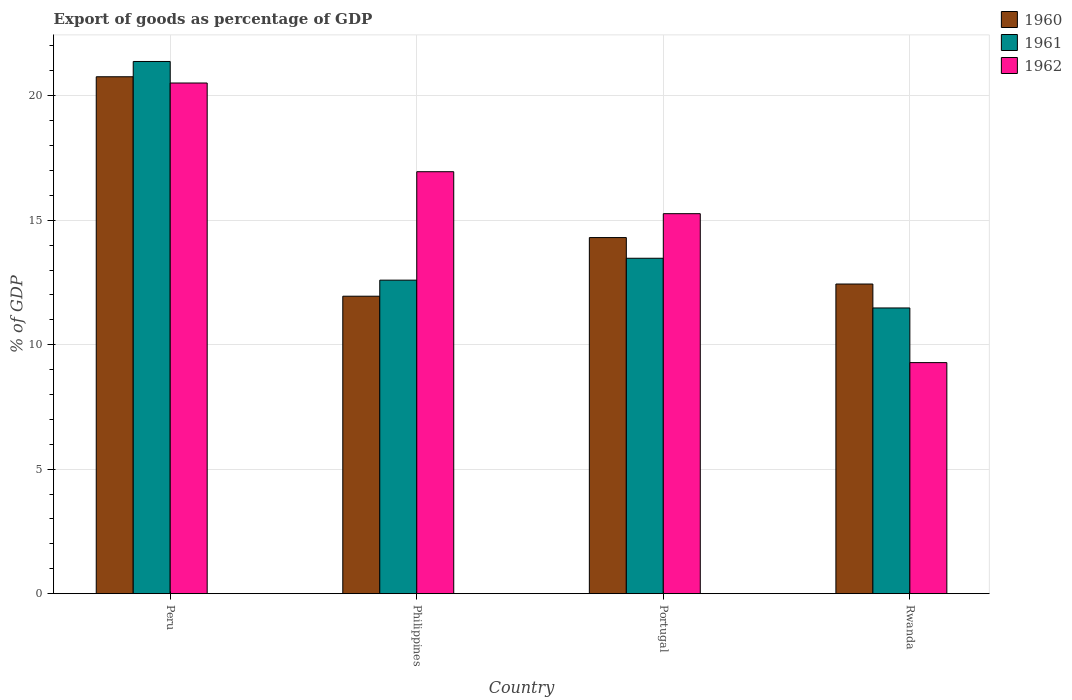Are the number of bars per tick equal to the number of legend labels?
Provide a succinct answer. Yes. Are the number of bars on each tick of the X-axis equal?
Make the answer very short. Yes. How many bars are there on the 2nd tick from the left?
Ensure brevity in your answer.  3. What is the export of goods as percentage of GDP in 1960 in Rwanda?
Provide a short and direct response. 12.44. Across all countries, what is the maximum export of goods as percentage of GDP in 1962?
Your answer should be very brief. 20.51. Across all countries, what is the minimum export of goods as percentage of GDP in 1960?
Provide a short and direct response. 11.95. In which country was the export of goods as percentage of GDP in 1961 minimum?
Keep it short and to the point. Rwanda. What is the total export of goods as percentage of GDP in 1960 in the graph?
Your response must be concise. 59.45. What is the difference between the export of goods as percentage of GDP in 1961 in Peru and that in Rwanda?
Keep it short and to the point. 9.9. What is the difference between the export of goods as percentage of GDP in 1961 in Portugal and the export of goods as percentage of GDP in 1960 in Rwanda?
Offer a very short reply. 1.03. What is the average export of goods as percentage of GDP in 1960 per country?
Offer a terse response. 14.86. What is the difference between the export of goods as percentage of GDP of/in 1960 and export of goods as percentage of GDP of/in 1962 in Rwanda?
Provide a short and direct response. 3.16. In how many countries, is the export of goods as percentage of GDP in 1962 greater than 20 %?
Your response must be concise. 1. What is the ratio of the export of goods as percentage of GDP in 1960 in Peru to that in Rwanda?
Provide a succinct answer. 1.67. Is the export of goods as percentage of GDP in 1962 in Peru less than that in Philippines?
Give a very brief answer. No. What is the difference between the highest and the second highest export of goods as percentage of GDP in 1961?
Ensure brevity in your answer.  0.88. What is the difference between the highest and the lowest export of goods as percentage of GDP in 1962?
Provide a short and direct response. 11.23. How many bars are there?
Your response must be concise. 12. Are all the bars in the graph horizontal?
Your response must be concise. No. How many countries are there in the graph?
Your answer should be very brief. 4. Does the graph contain grids?
Ensure brevity in your answer.  Yes. How many legend labels are there?
Provide a short and direct response. 3. What is the title of the graph?
Offer a very short reply. Export of goods as percentage of GDP. What is the label or title of the X-axis?
Your answer should be very brief. Country. What is the label or title of the Y-axis?
Offer a terse response. % of GDP. What is the % of GDP of 1960 in Peru?
Offer a very short reply. 20.76. What is the % of GDP of 1961 in Peru?
Give a very brief answer. 21.38. What is the % of GDP in 1962 in Peru?
Offer a terse response. 20.51. What is the % of GDP in 1960 in Philippines?
Your response must be concise. 11.95. What is the % of GDP of 1961 in Philippines?
Keep it short and to the point. 12.59. What is the % of GDP of 1962 in Philippines?
Your answer should be very brief. 16.95. What is the % of GDP of 1960 in Portugal?
Make the answer very short. 14.3. What is the % of GDP of 1961 in Portugal?
Provide a short and direct response. 13.47. What is the % of GDP in 1962 in Portugal?
Your answer should be very brief. 15.26. What is the % of GDP in 1960 in Rwanda?
Ensure brevity in your answer.  12.44. What is the % of GDP of 1961 in Rwanda?
Provide a succinct answer. 11.48. What is the % of GDP in 1962 in Rwanda?
Provide a short and direct response. 9.28. Across all countries, what is the maximum % of GDP in 1960?
Provide a succinct answer. 20.76. Across all countries, what is the maximum % of GDP of 1961?
Offer a very short reply. 21.38. Across all countries, what is the maximum % of GDP in 1962?
Ensure brevity in your answer.  20.51. Across all countries, what is the minimum % of GDP in 1960?
Your response must be concise. 11.95. Across all countries, what is the minimum % of GDP in 1961?
Keep it short and to the point. 11.48. Across all countries, what is the minimum % of GDP of 1962?
Offer a very short reply. 9.28. What is the total % of GDP in 1960 in the graph?
Your answer should be very brief. 59.45. What is the total % of GDP of 1961 in the graph?
Keep it short and to the point. 58.91. What is the total % of GDP in 1962 in the graph?
Offer a very short reply. 62. What is the difference between the % of GDP in 1960 in Peru and that in Philippines?
Provide a short and direct response. 8.81. What is the difference between the % of GDP of 1961 in Peru and that in Philippines?
Ensure brevity in your answer.  8.78. What is the difference between the % of GDP of 1962 in Peru and that in Philippines?
Your response must be concise. 3.56. What is the difference between the % of GDP in 1960 in Peru and that in Portugal?
Ensure brevity in your answer.  6.46. What is the difference between the % of GDP of 1961 in Peru and that in Portugal?
Give a very brief answer. 7.9. What is the difference between the % of GDP in 1962 in Peru and that in Portugal?
Make the answer very short. 5.25. What is the difference between the % of GDP of 1960 in Peru and that in Rwanda?
Ensure brevity in your answer.  8.32. What is the difference between the % of GDP of 1961 in Peru and that in Rwanda?
Keep it short and to the point. 9.9. What is the difference between the % of GDP in 1962 in Peru and that in Rwanda?
Give a very brief answer. 11.23. What is the difference between the % of GDP of 1960 in Philippines and that in Portugal?
Provide a short and direct response. -2.36. What is the difference between the % of GDP in 1961 in Philippines and that in Portugal?
Keep it short and to the point. -0.88. What is the difference between the % of GDP of 1962 in Philippines and that in Portugal?
Keep it short and to the point. 1.69. What is the difference between the % of GDP in 1960 in Philippines and that in Rwanda?
Your answer should be compact. -0.49. What is the difference between the % of GDP in 1961 in Philippines and that in Rwanda?
Provide a short and direct response. 1.12. What is the difference between the % of GDP in 1962 in Philippines and that in Rwanda?
Your answer should be very brief. 7.67. What is the difference between the % of GDP in 1960 in Portugal and that in Rwanda?
Your answer should be compact. 1.87. What is the difference between the % of GDP of 1961 in Portugal and that in Rwanda?
Provide a succinct answer. 2. What is the difference between the % of GDP in 1962 in Portugal and that in Rwanda?
Your answer should be compact. 5.98. What is the difference between the % of GDP in 1960 in Peru and the % of GDP in 1961 in Philippines?
Provide a succinct answer. 8.17. What is the difference between the % of GDP of 1960 in Peru and the % of GDP of 1962 in Philippines?
Offer a very short reply. 3.81. What is the difference between the % of GDP in 1961 in Peru and the % of GDP in 1962 in Philippines?
Ensure brevity in your answer.  4.43. What is the difference between the % of GDP in 1960 in Peru and the % of GDP in 1961 in Portugal?
Give a very brief answer. 7.29. What is the difference between the % of GDP in 1960 in Peru and the % of GDP in 1962 in Portugal?
Offer a very short reply. 5.5. What is the difference between the % of GDP in 1961 in Peru and the % of GDP in 1962 in Portugal?
Make the answer very short. 6.11. What is the difference between the % of GDP in 1960 in Peru and the % of GDP in 1961 in Rwanda?
Offer a very short reply. 9.29. What is the difference between the % of GDP of 1960 in Peru and the % of GDP of 1962 in Rwanda?
Your answer should be very brief. 11.48. What is the difference between the % of GDP of 1961 in Peru and the % of GDP of 1962 in Rwanda?
Ensure brevity in your answer.  12.1. What is the difference between the % of GDP in 1960 in Philippines and the % of GDP in 1961 in Portugal?
Offer a terse response. -1.52. What is the difference between the % of GDP of 1960 in Philippines and the % of GDP of 1962 in Portugal?
Ensure brevity in your answer.  -3.31. What is the difference between the % of GDP in 1961 in Philippines and the % of GDP in 1962 in Portugal?
Your answer should be very brief. -2.67. What is the difference between the % of GDP of 1960 in Philippines and the % of GDP of 1961 in Rwanda?
Provide a short and direct response. 0.47. What is the difference between the % of GDP of 1960 in Philippines and the % of GDP of 1962 in Rwanda?
Your response must be concise. 2.67. What is the difference between the % of GDP of 1961 in Philippines and the % of GDP of 1962 in Rwanda?
Ensure brevity in your answer.  3.31. What is the difference between the % of GDP in 1960 in Portugal and the % of GDP in 1961 in Rwanda?
Your response must be concise. 2.83. What is the difference between the % of GDP of 1960 in Portugal and the % of GDP of 1962 in Rwanda?
Make the answer very short. 5.02. What is the difference between the % of GDP in 1961 in Portugal and the % of GDP in 1962 in Rwanda?
Ensure brevity in your answer.  4.19. What is the average % of GDP in 1960 per country?
Provide a short and direct response. 14.86. What is the average % of GDP of 1961 per country?
Your answer should be compact. 14.73. What is the average % of GDP of 1962 per country?
Your answer should be compact. 15.5. What is the difference between the % of GDP of 1960 and % of GDP of 1961 in Peru?
Your response must be concise. -0.61. What is the difference between the % of GDP in 1960 and % of GDP in 1962 in Peru?
Your answer should be very brief. 0.25. What is the difference between the % of GDP of 1961 and % of GDP of 1962 in Peru?
Ensure brevity in your answer.  0.86. What is the difference between the % of GDP of 1960 and % of GDP of 1961 in Philippines?
Your answer should be compact. -0.65. What is the difference between the % of GDP in 1960 and % of GDP in 1962 in Philippines?
Provide a short and direct response. -5. What is the difference between the % of GDP of 1961 and % of GDP of 1962 in Philippines?
Keep it short and to the point. -4.36. What is the difference between the % of GDP in 1960 and % of GDP in 1961 in Portugal?
Your answer should be compact. 0.83. What is the difference between the % of GDP of 1960 and % of GDP of 1962 in Portugal?
Your answer should be very brief. -0.96. What is the difference between the % of GDP in 1961 and % of GDP in 1962 in Portugal?
Give a very brief answer. -1.79. What is the difference between the % of GDP of 1960 and % of GDP of 1961 in Rwanda?
Provide a succinct answer. 0.96. What is the difference between the % of GDP in 1960 and % of GDP in 1962 in Rwanda?
Your answer should be compact. 3.16. What is the difference between the % of GDP in 1961 and % of GDP in 1962 in Rwanda?
Your answer should be compact. 2.2. What is the ratio of the % of GDP in 1960 in Peru to that in Philippines?
Provide a short and direct response. 1.74. What is the ratio of the % of GDP of 1961 in Peru to that in Philippines?
Make the answer very short. 1.7. What is the ratio of the % of GDP in 1962 in Peru to that in Philippines?
Provide a succinct answer. 1.21. What is the ratio of the % of GDP of 1960 in Peru to that in Portugal?
Provide a short and direct response. 1.45. What is the ratio of the % of GDP of 1961 in Peru to that in Portugal?
Ensure brevity in your answer.  1.59. What is the ratio of the % of GDP in 1962 in Peru to that in Portugal?
Give a very brief answer. 1.34. What is the ratio of the % of GDP in 1960 in Peru to that in Rwanda?
Your response must be concise. 1.67. What is the ratio of the % of GDP in 1961 in Peru to that in Rwanda?
Make the answer very short. 1.86. What is the ratio of the % of GDP of 1962 in Peru to that in Rwanda?
Keep it short and to the point. 2.21. What is the ratio of the % of GDP in 1960 in Philippines to that in Portugal?
Your response must be concise. 0.84. What is the ratio of the % of GDP in 1961 in Philippines to that in Portugal?
Offer a terse response. 0.93. What is the ratio of the % of GDP in 1962 in Philippines to that in Portugal?
Provide a short and direct response. 1.11. What is the ratio of the % of GDP of 1960 in Philippines to that in Rwanda?
Offer a very short reply. 0.96. What is the ratio of the % of GDP in 1961 in Philippines to that in Rwanda?
Ensure brevity in your answer.  1.1. What is the ratio of the % of GDP in 1962 in Philippines to that in Rwanda?
Give a very brief answer. 1.83. What is the ratio of the % of GDP of 1960 in Portugal to that in Rwanda?
Your answer should be very brief. 1.15. What is the ratio of the % of GDP of 1961 in Portugal to that in Rwanda?
Your answer should be compact. 1.17. What is the ratio of the % of GDP in 1962 in Portugal to that in Rwanda?
Your answer should be very brief. 1.64. What is the difference between the highest and the second highest % of GDP of 1960?
Ensure brevity in your answer.  6.46. What is the difference between the highest and the second highest % of GDP in 1961?
Your response must be concise. 7.9. What is the difference between the highest and the second highest % of GDP in 1962?
Keep it short and to the point. 3.56. What is the difference between the highest and the lowest % of GDP of 1960?
Provide a short and direct response. 8.81. What is the difference between the highest and the lowest % of GDP of 1961?
Offer a very short reply. 9.9. What is the difference between the highest and the lowest % of GDP in 1962?
Give a very brief answer. 11.23. 